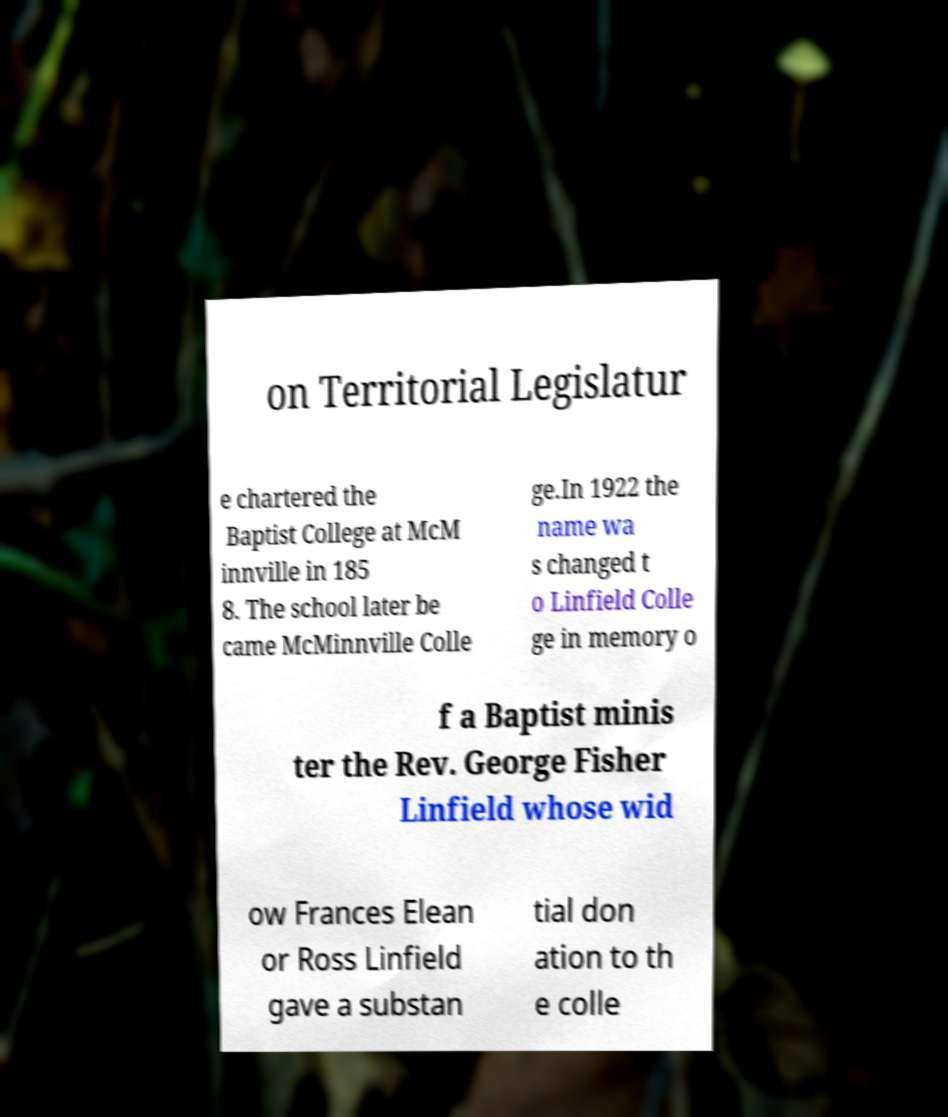Could you extract and type out the text from this image? on Territorial Legislatur e chartered the Baptist College at McM innville in 185 8. The school later be came McMinnville Colle ge.In 1922 the name wa s changed t o Linfield Colle ge in memory o f a Baptist minis ter the Rev. George Fisher Linfield whose wid ow Frances Elean or Ross Linfield gave a substan tial don ation to th e colle 